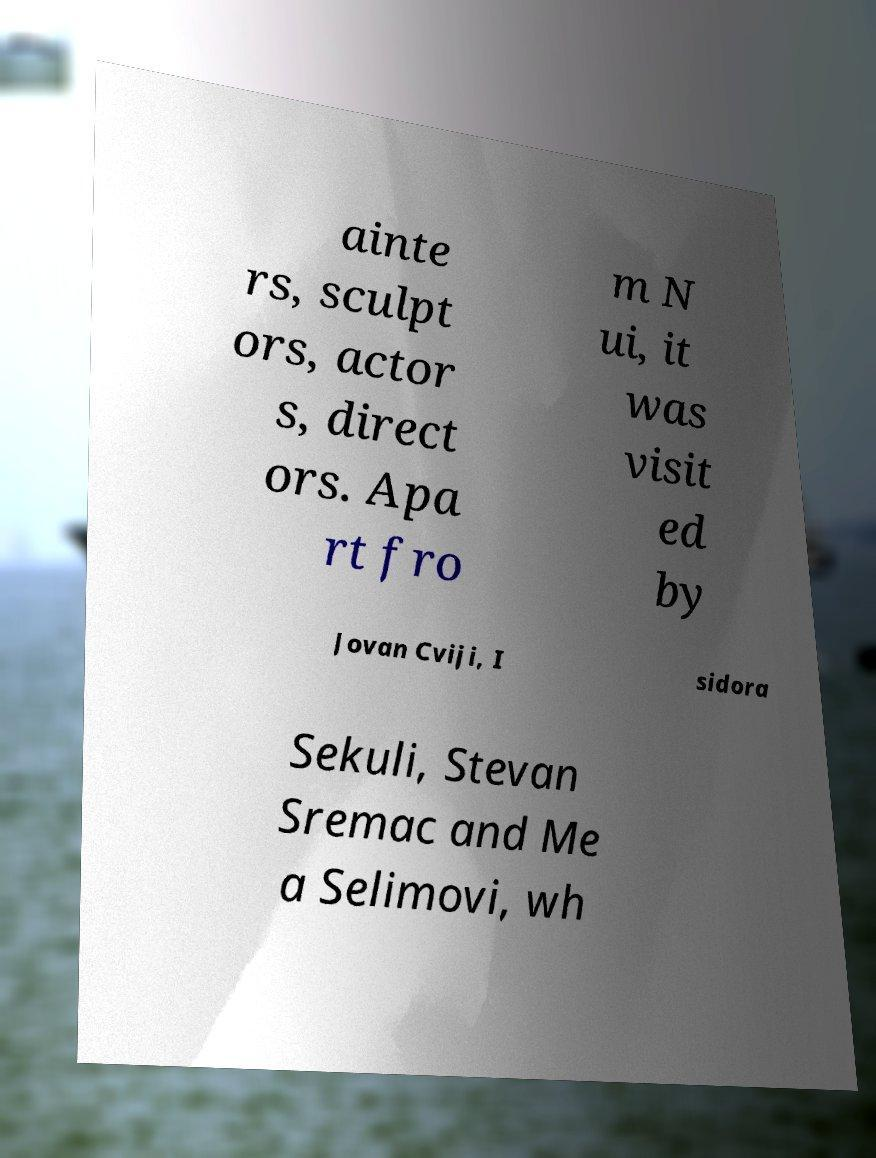I need the written content from this picture converted into text. Can you do that? ainte rs, sculpt ors, actor s, direct ors. Apa rt fro m N ui, it was visit ed by Jovan Cviji, I sidora Sekuli, Stevan Sremac and Me a Selimovi, wh 